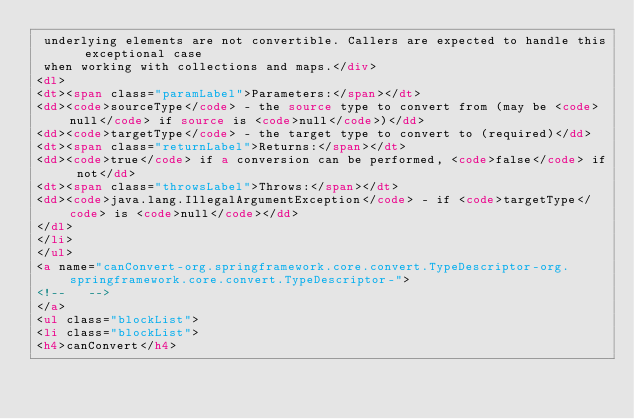Convert code to text. <code><loc_0><loc_0><loc_500><loc_500><_HTML_> underlying elements are not convertible. Callers are expected to handle this exceptional case
 when working with collections and maps.</div>
<dl>
<dt><span class="paramLabel">Parameters:</span></dt>
<dd><code>sourceType</code> - the source type to convert from (may be <code>null</code> if source is <code>null</code>)</dd>
<dd><code>targetType</code> - the target type to convert to (required)</dd>
<dt><span class="returnLabel">Returns:</span></dt>
<dd><code>true</code> if a conversion can be performed, <code>false</code> if not</dd>
<dt><span class="throwsLabel">Throws:</span></dt>
<dd><code>java.lang.IllegalArgumentException</code> - if <code>targetType</code> is <code>null</code></dd>
</dl>
</li>
</ul>
<a name="canConvert-org.springframework.core.convert.TypeDescriptor-org.springframework.core.convert.TypeDescriptor-">
<!--   -->
</a>
<ul class="blockList">
<li class="blockList">
<h4>canConvert</h4></code> 